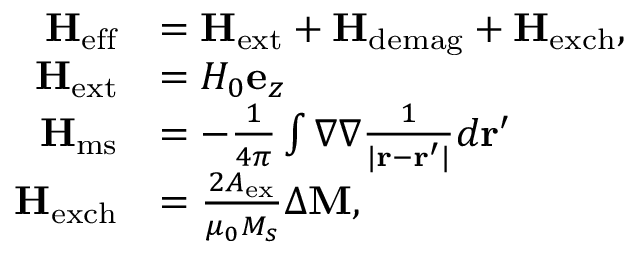Convert formula to latex. <formula><loc_0><loc_0><loc_500><loc_500>\begin{array} { r l } { H _ { e f f } } & { = H _ { e x t } + H _ { d e m a g } + H _ { e x c h } , } \\ { H _ { e x t } } & { = H _ { 0 } e _ { z } } \\ { H _ { m s } } & { = - \frac { 1 } { 4 \pi } \int \nabla \nabla \frac { 1 } { | r - r ^ { \prime } | } d r ^ { \prime } } \\ { H _ { e x c h } } & { = \frac { 2 A _ { e x } } { \mu _ { 0 } M _ { s } } \Delta M , } \end{array}</formula> 